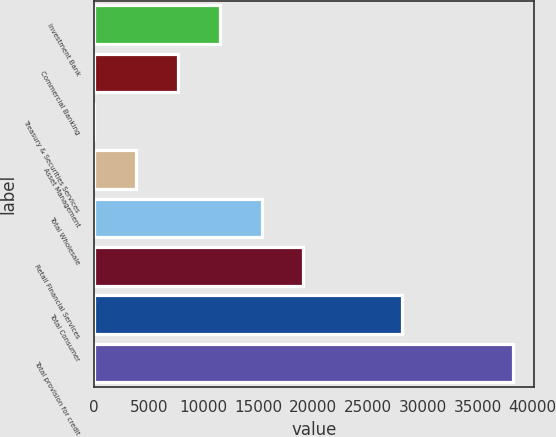Convert chart. <chart><loc_0><loc_0><loc_500><loc_500><bar_chart><fcel>Investment Bank<fcel>Commercial Banking<fcel>Treasury & Securities Services<fcel>Asset Management<fcel>Total Wholesale<fcel>Retail Financial Services<fcel>Total Consumer<fcel>Total provision for credit<nl><fcel>11477.2<fcel>7662.8<fcel>34<fcel>3848.4<fcel>15291.6<fcel>19106<fcel>28051<fcel>38178<nl></chart> 